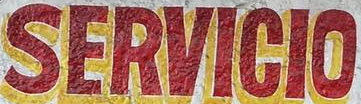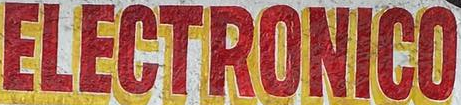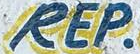What text is displayed in these images sequentially, separated by a semicolon? SERVICIO; ELECTRONICO; REP 